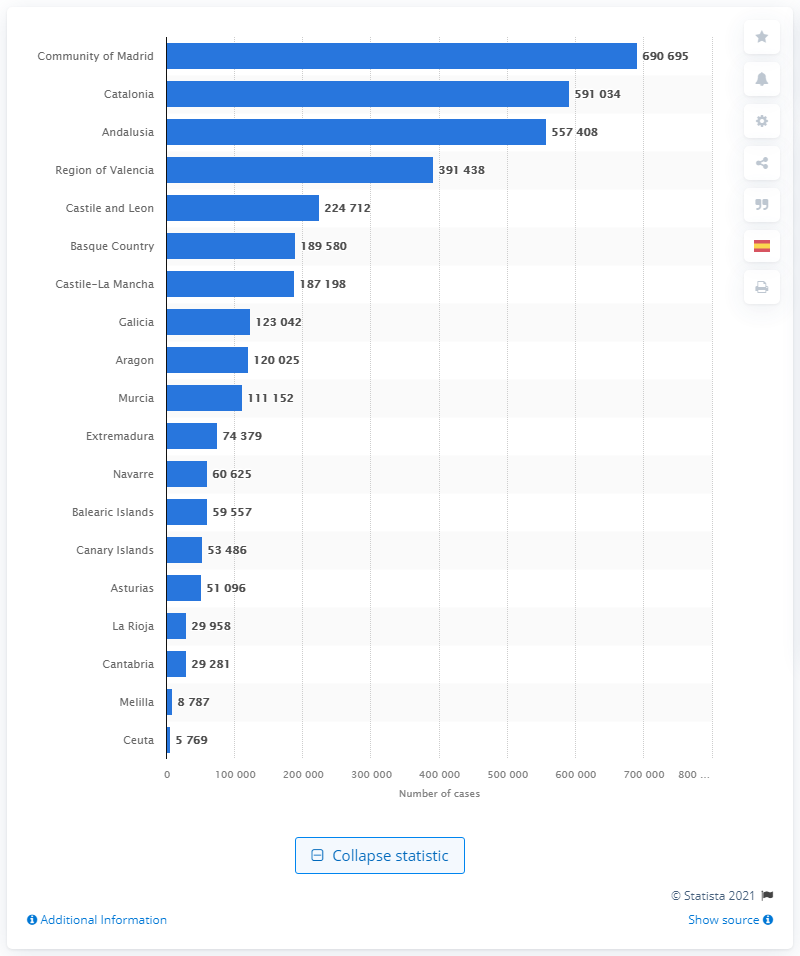Identify some key points in this picture. As of March 26, 2022, it is estimated that a total of 690,695 people in Madrid have been affected by COVID-19. 